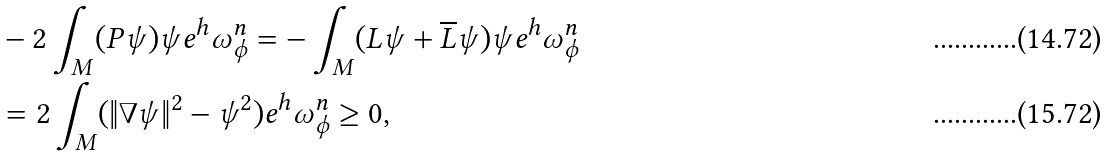<formula> <loc_0><loc_0><loc_500><loc_500>& - 2 \int _ { M } ( P \psi ) \psi e ^ { h } \omega _ { \phi } ^ { n } = - \int _ { M } ( L \psi + \overline { L } \psi ) \psi e ^ { h } \omega _ { \phi } ^ { n } \\ & = 2 \int _ { M } ( \| \nabla \psi \| ^ { 2 } - \psi ^ { 2 } ) e ^ { h } \omega _ { \phi } ^ { n } \geq 0 ,</formula> 